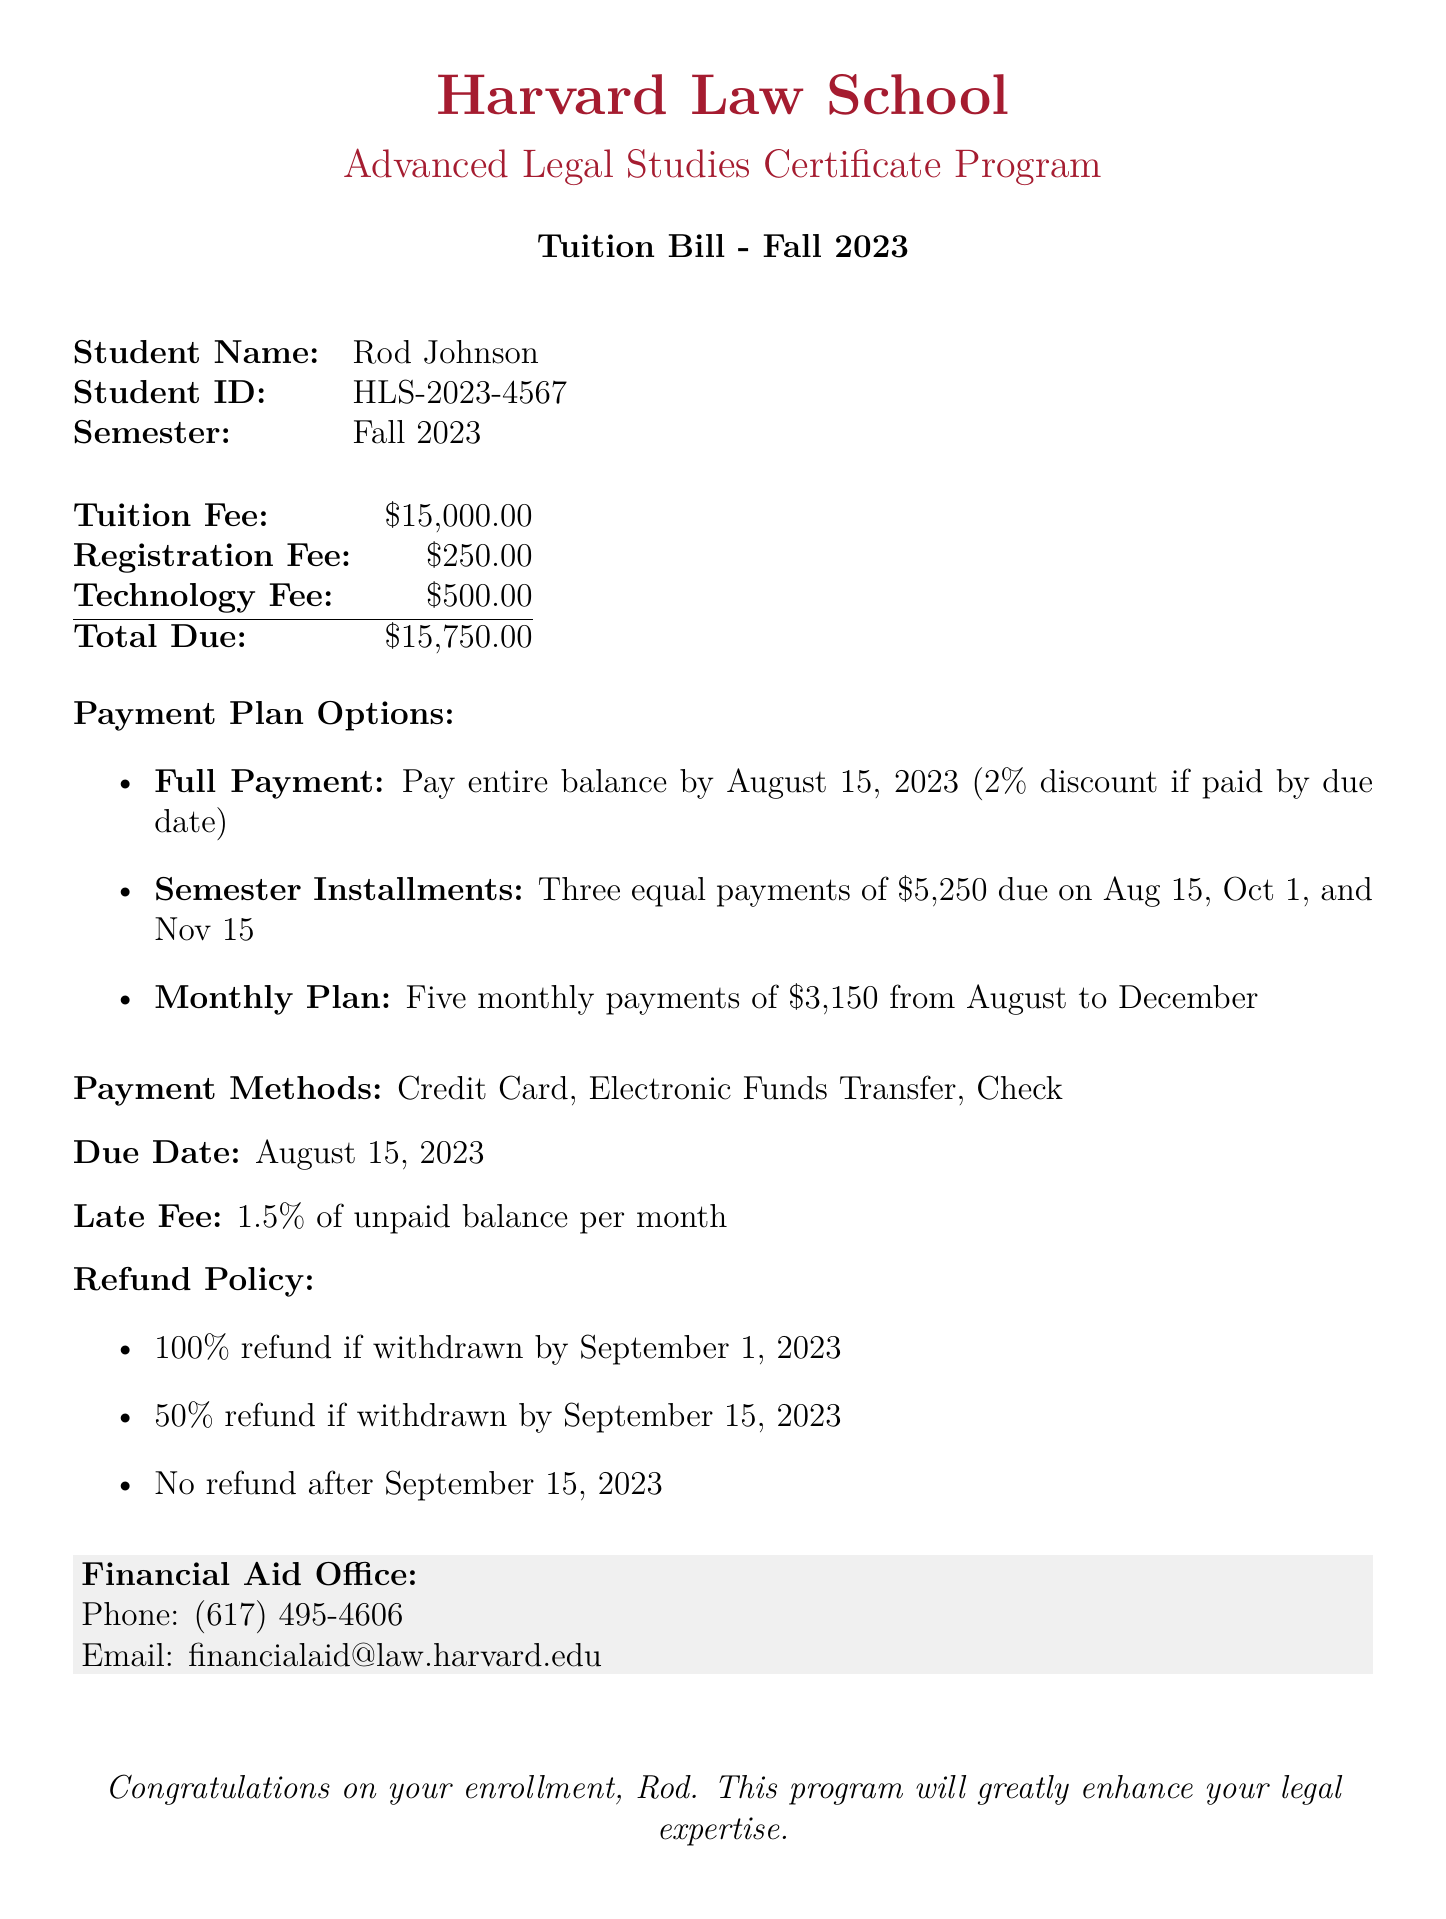What is the total due for tuition? The total due is the sum of the tuition fee, registration fee, and technology fee, which equals $15,000.00 + $250.00 + $500.00.
Answer: $15,750.00 What is the registration fee? The registration fee is explicitly stated in the document as $250.00.
Answer: $250.00 What is the due date for the payment? The due date for the payment is specified in the document as August 15, 2023.
Answer: August 15, 2023 What is the refund policy for withdrawal by September 1, 2023? The refund policy states that a 100% refund is available if the student withdraws by September 1, 2023.
Answer: 100% refund How many monthly payments are in the Monthly Plan option? The Monthly Plan option specifies that there are five monthly payments from August to December.
Answer: Five What is the technology fee? The technology fee stated in the document is $500.00.
Answer: $500.00 What discount is offered for full payment by the due date? The document mentions a 2% discount for paying the entire balance by the due date.
Answer: 2% How much is each installment in the Semester Installments option? The Semester Installments option states that there are three equal payments of $5,250 due at specified times.
Answer: $5,250 What percentage is charged as a late fee? The document indicates that a late fee of 1.5% of the unpaid balance is charged per month.
Answer: 1.5% 